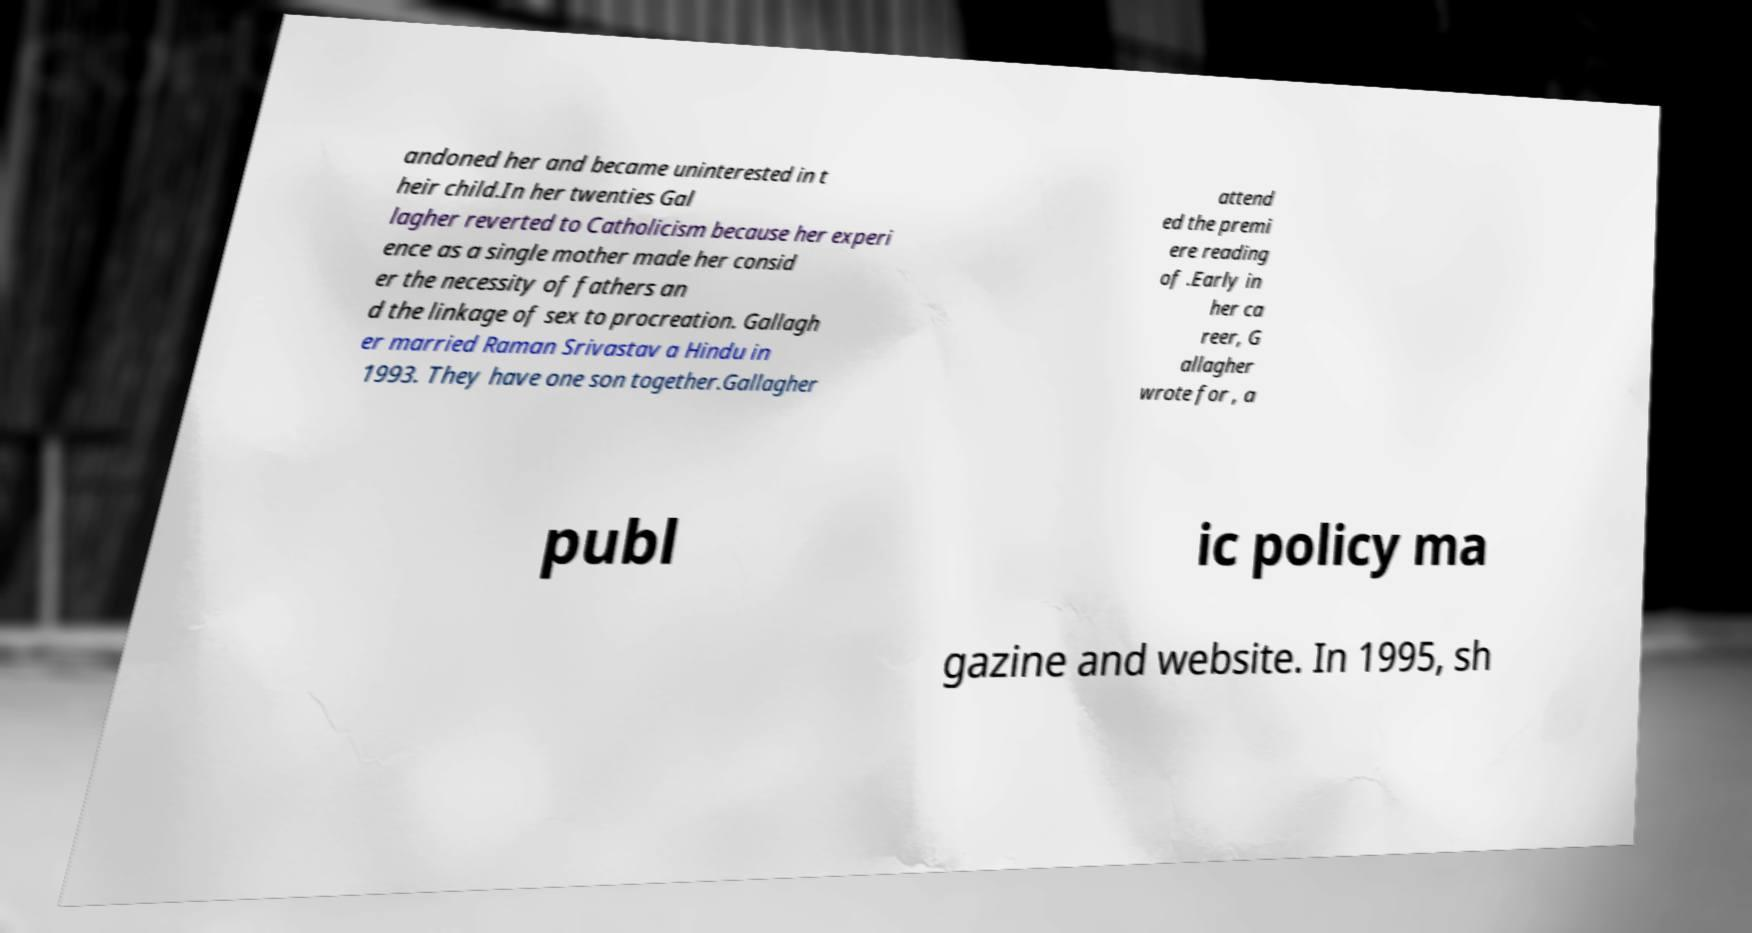Could you assist in decoding the text presented in this image and type it out clearly? andoned her and became uninterested in t heir child.In her twenties Gal lagher reverted to Catholicism because her experi ence as a single mother made her consid er the necessity of fathers an d the linkage of sex to procreation. Gallagh er married Raman Srivastav a Hindu in 1993. They have one son together.Gallagher attend ed the premi ere reading of .Early in her ca reer, G allagher wrote for , a publ ic policy ma gazine and website. In 1995, sh 